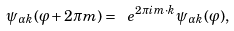Convert formula to latex. <formula><loc_0><loc_0><loc_500><loc_500>\psi _ { \alpha { k } } ( \varphi + 2 \pi { m } ) = \ e ^ { 2 \pi i { m } \cdot { k } } \psi _ { \alpha { k } } ( \varphi ) ,</formula> 